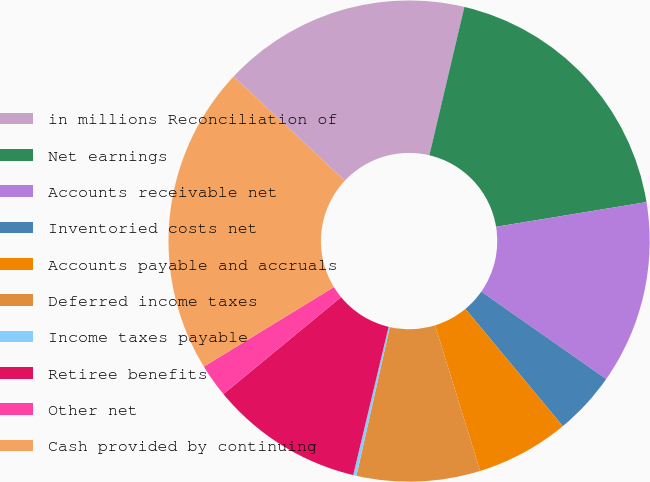Convert chart. <chart><loc_0><loc_0><loc_500><loc_500><pie_chart><fcel>in millions Reconciliation of<fcel>Net earnings<fcel>Accounts receivable net<fcel>Inventoried costs net<fcel>Accounts payable and accruals<fcel>Deferred income taxes<fcel>Income taxes payable<fcel>Retiree benefits<fcel>Other net<fcel>Cash provided by continuing<nl><fcel>16.7%<fcel>18.72%<fcel>12.31%<fcel>4.25%<fcel>6.26%<fcel>8.28%<fcel>0.22%<fcel>10.3%<fcel>2.23%<fcel>20.73%<nl></chart> 